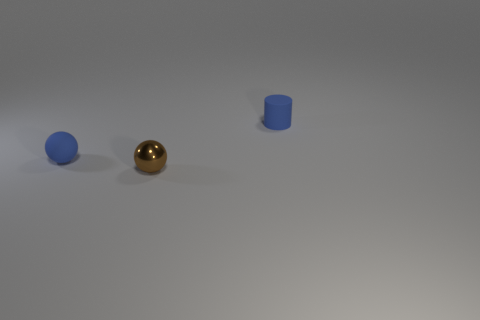Subtract all red balls. Subtract all yellow blocks. How many balls are left? 2 Add 3 large gray metallic objects. How many objects exist? 6 Subtract all balls. How many objects are left? 1 Subtract 0 blue cubes. How many objects are left? 3 Subtract all large cyan cylinders. Subtract all small blue cylinders. How many objects are left? 2 Add 2 metallic things. How many metallic things are left? 3 Add 1 tiny shiny things. How many tiny shiny things exist? 2 